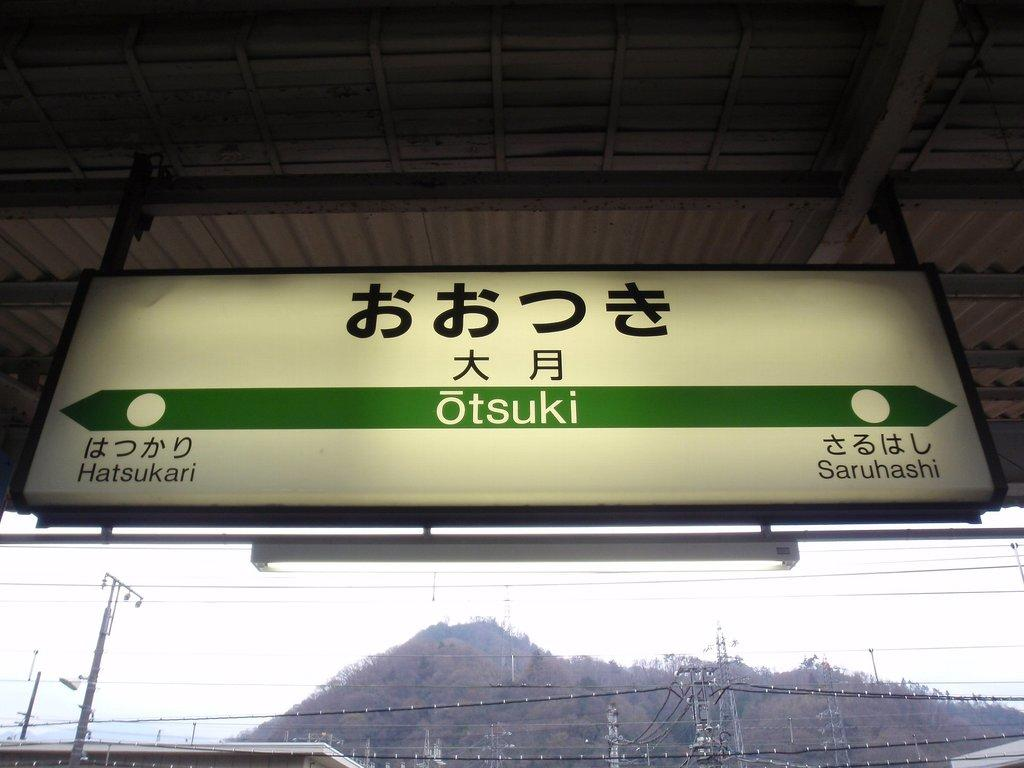<image>
Provide a brief description of the given image. A sign shows the current location, Otsuki, the names of the next stations are shown. 